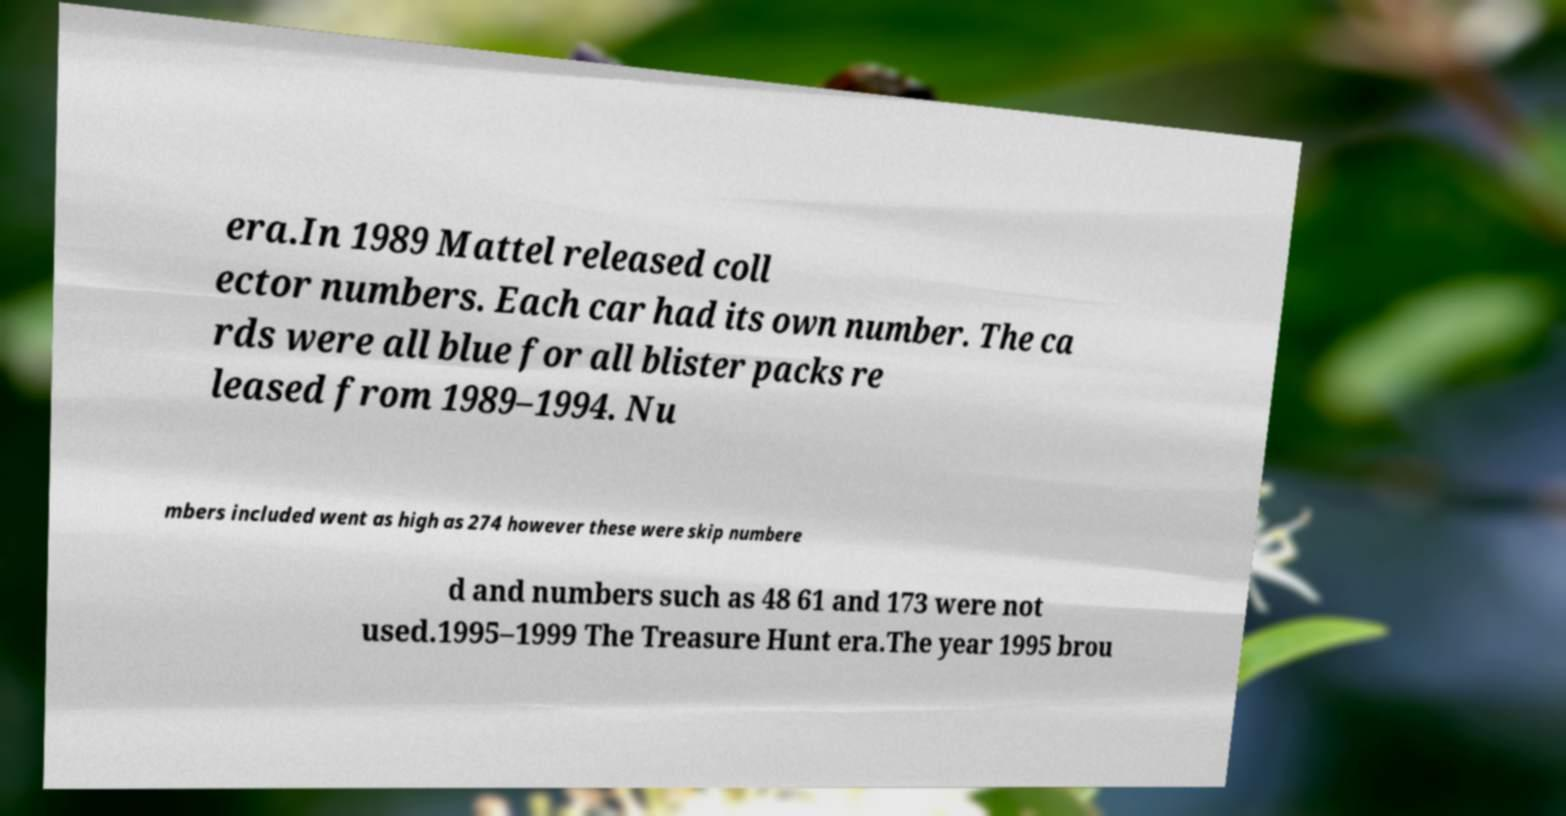Could you extract and type out the text from this image? era.In 1989 Mattel released coll ector numbers. Each car had its own number. The ca rds were all blue for all blister packs re leased from 1989–1994. Nu mbers included went as high as 274 however these were skip numbere d and numbers such as 48 61 and 173 were not used.1995–1999 The Treasure Hunt era.The year 1995 brou 